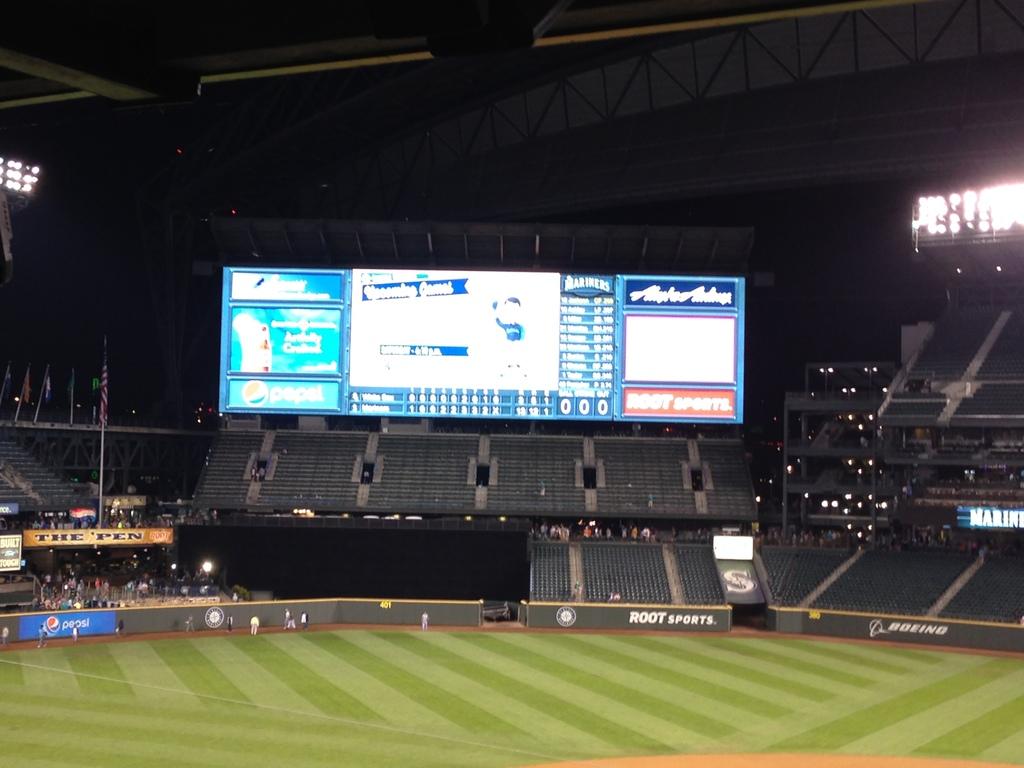What soda is advertised on the back wall?
Ensure brevity in your answer.  Pepsi. 